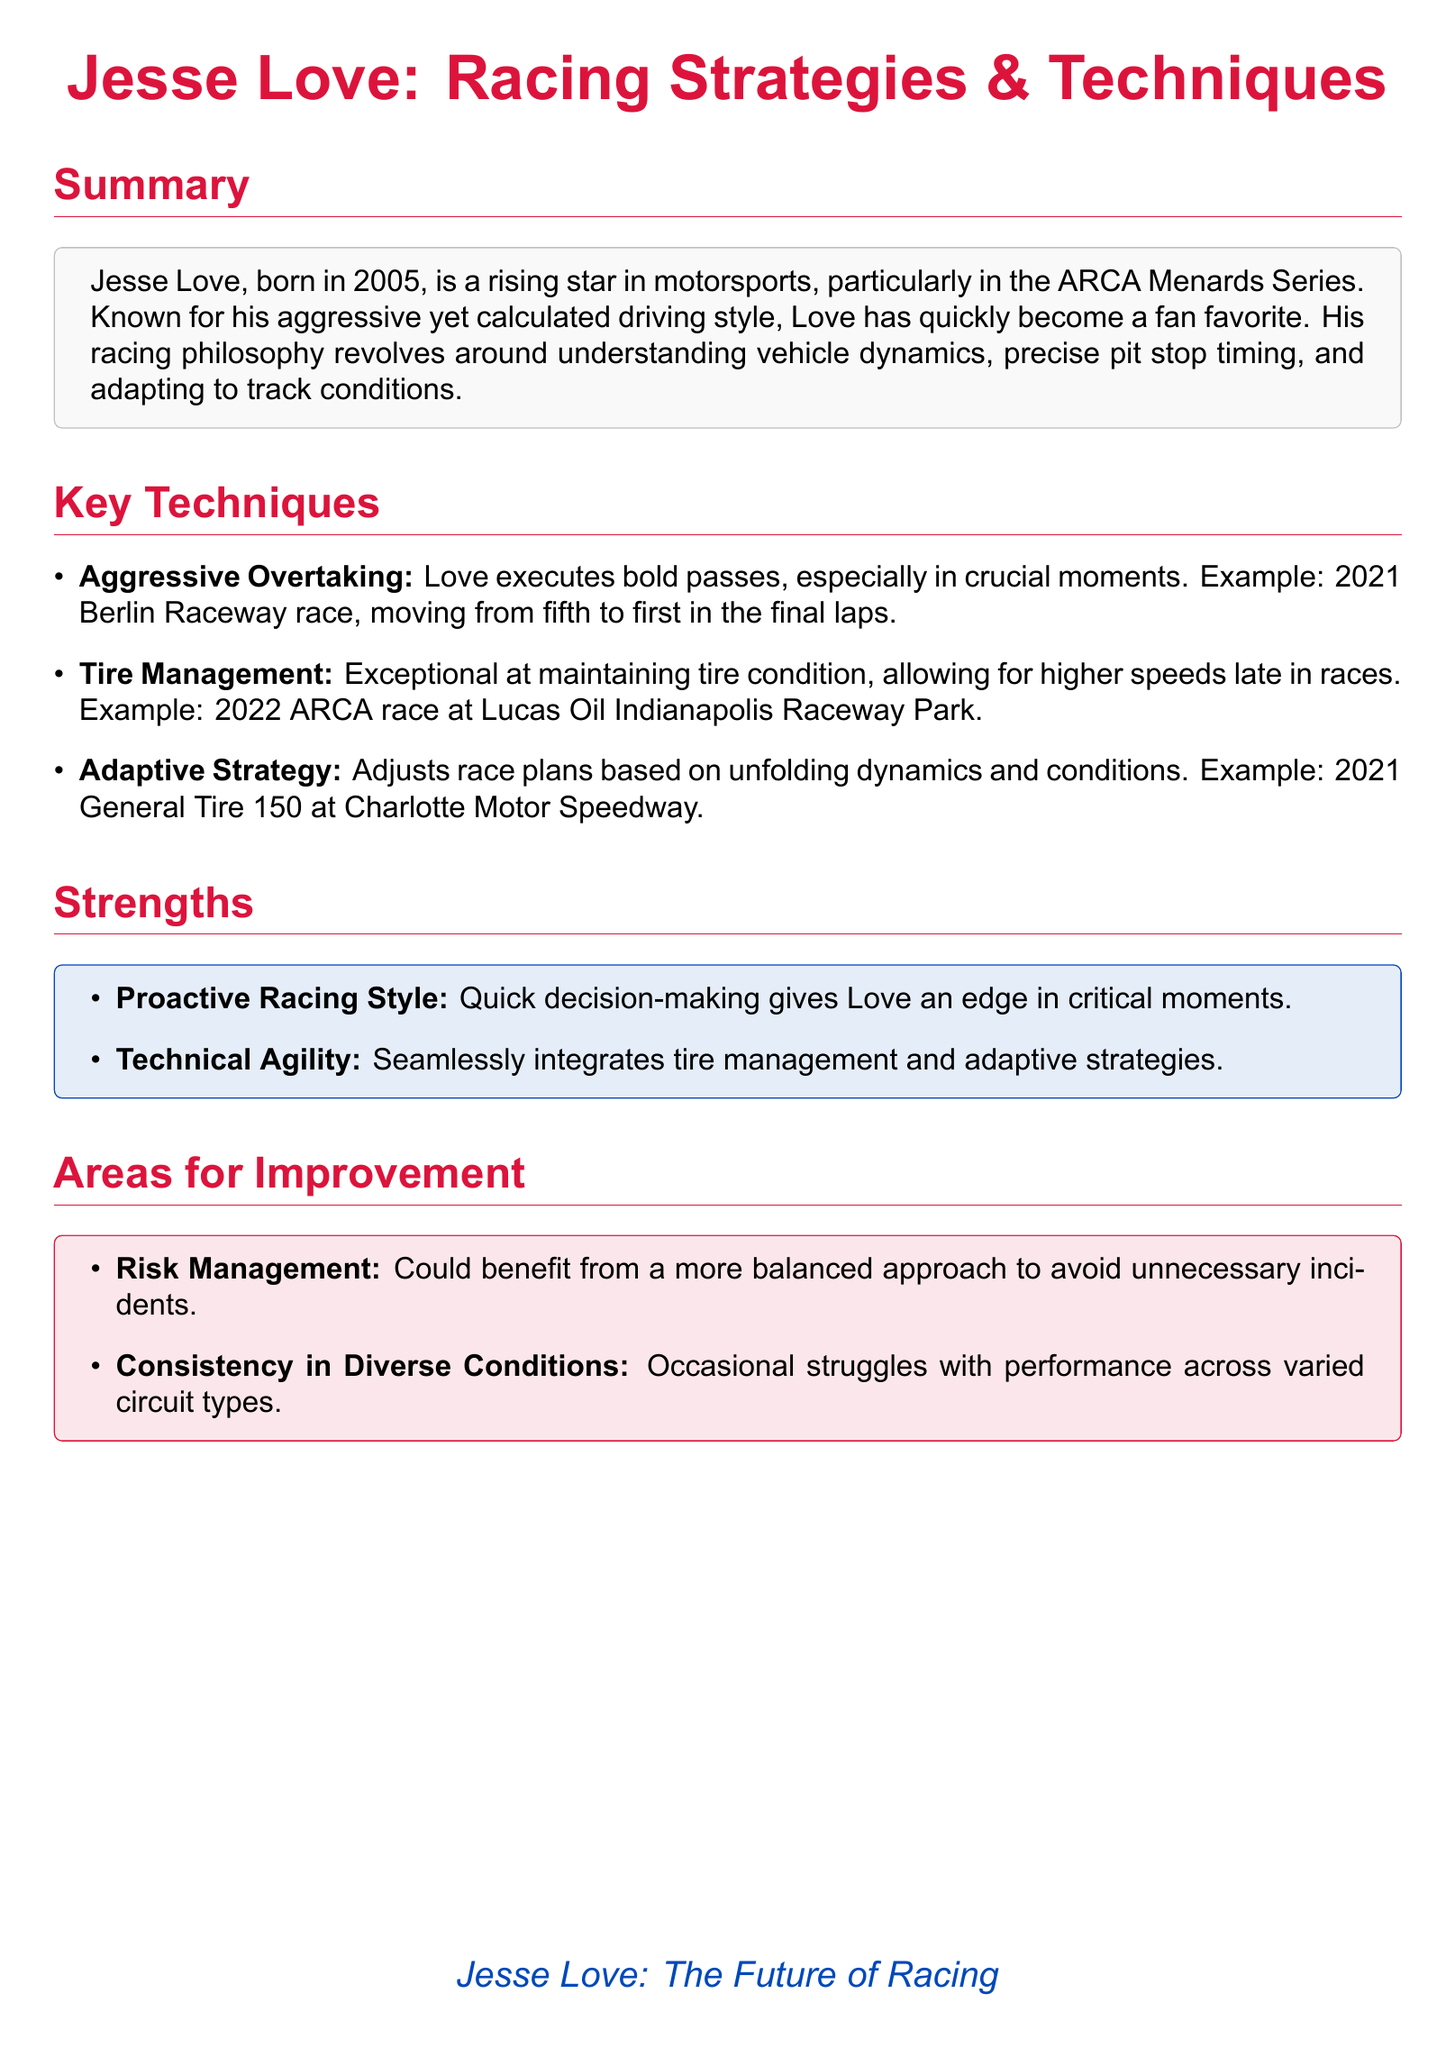What year was Jesse Love born? The document specifies that Jesse Love was born in 2005.
Answer: 2005 What racing series is Jesse Love known for? The summary mentions that he is particularly known for his performance in the ARCA Menards Series.
Answer: ARCA Menards Series In which race did Jesse Love move from fifth to first place? The document provides an example where he executed a bold pass at the 2021 Berlin Raceway race, moving from fifth to first.
Answer: 2021 Berlin Raceway What key technique involves exceptional tire condition management? The document lists tire management as one of Love's key techniques, highlighted in the 2022 ARCA race at Lucas Oil Indianapolis Raceway Park.
Answer: Tire Management What is a noted strength regarding Jesse Love's racing style? The strengths section highlights Love's quick decision-making as a proactive racing style that gives him an edge.
Answer: Quick decision-making What area for improvement is mentioned regarding risk? The document discusses that Love could benefit from a more balanced approach to risk management.
Answer: Risk Management In which race did Jesse Love demonstrate an adaptive strategy? The document mentions an example of adaptive strategy in the 2021 General Tire 150 at Charlotte Motor Speedway.
Answer: 2021 General Tire 150 What is one of the documented weaknesses in Jesse Love's performance? Consistency in diverse conditions is noted as an area for improvement for Love.
Answer: Consistency in Diverse Conditions What color is the title "Jesse Love: Racing Strategies & Techniques"? The title is rendered in racing red color, as indicated in the document.
Answer: Racing Red 